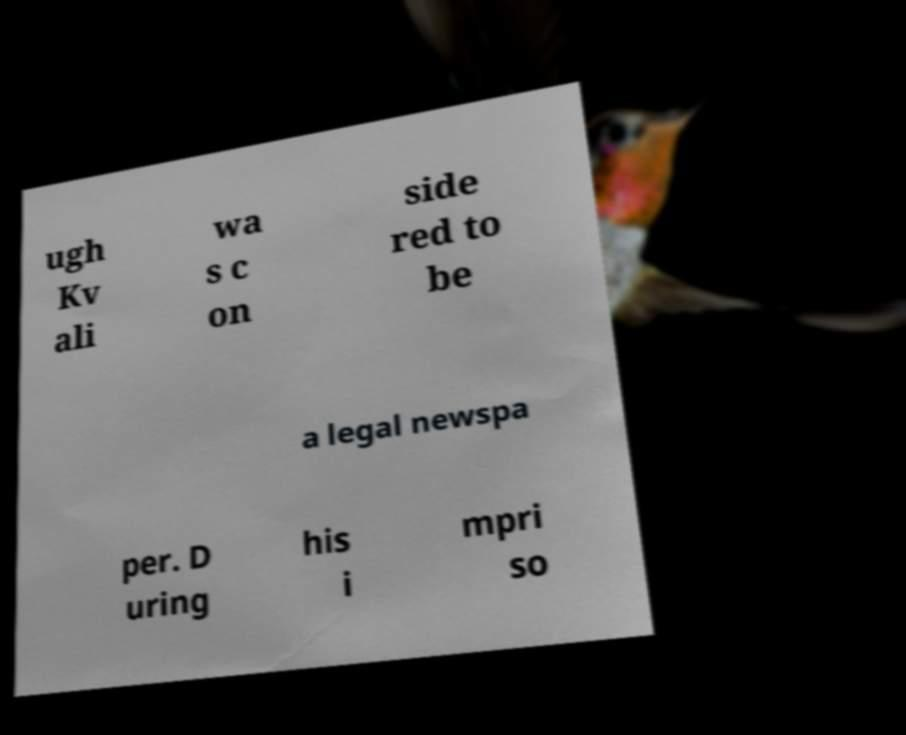Can you accurately transcribe the text from the provided image for me? ugh Kv ali wa s c on side red to be a legal newspa per. D uring his i mpri so 